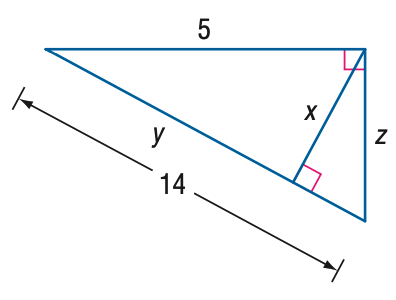Answer the mathemtical geometry problem and directly provide the correct option letter.
Question: Find x.
Choices: A: \frac { 5 } { 14 } \sqrt { 19 } B: \frac { 15 } { 14 } \sqrt { 19 } C: 5 D: 14 B 